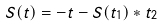<formula> <loc_0><loc_0><loc_500><loc_500>S ( t ) = - t - S ( t _ { 1 } ) \ast t _ { 2 }</formula> 